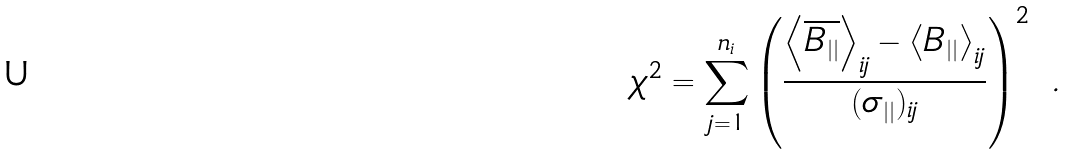<formula> <loc_0><loc_0><loc_500><loc_500>\chi ^ { 2 } = \sum ^ { n _ { i } } _ { j = 1 } \left ( \frac { \left < \overline { B _ { | | } } \right > _ { i j } - \left < B _ { | | } \right > _ { i j } } { ( \sigma _ { | | } ) _ { i j } } \right ) ^ { 2 } \ .</formula> 